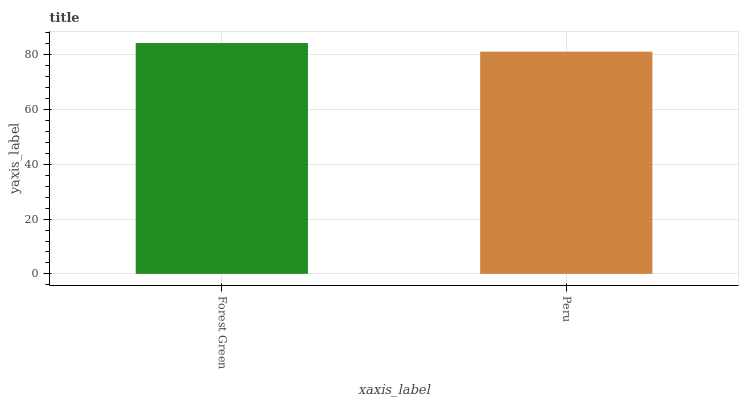Is Peru the minimum?
Answer yes or no. Yes. Is Forest Green the maximum?
Answer yes or no. Yes. Is Peru the maximum?
Answer yes or no. No. Is Forest Green greater than Peru?
Answer yes or no. Yes. Is Peru less than Forest Green?
Answer yes or no. Yes. Is Peru greater than Forest Green?
Answer yes or no. No. Is Forest Green less than Peru?
Answer yes or no. No. Is Forest Green the high median?
Answer yes or no. Yes. Is Peru the low median?
Answer yes or no. Yes. Is Peru the high median?
Answer yes or no. No. Is Forest Green the low median?
Answer yes or no. No. 